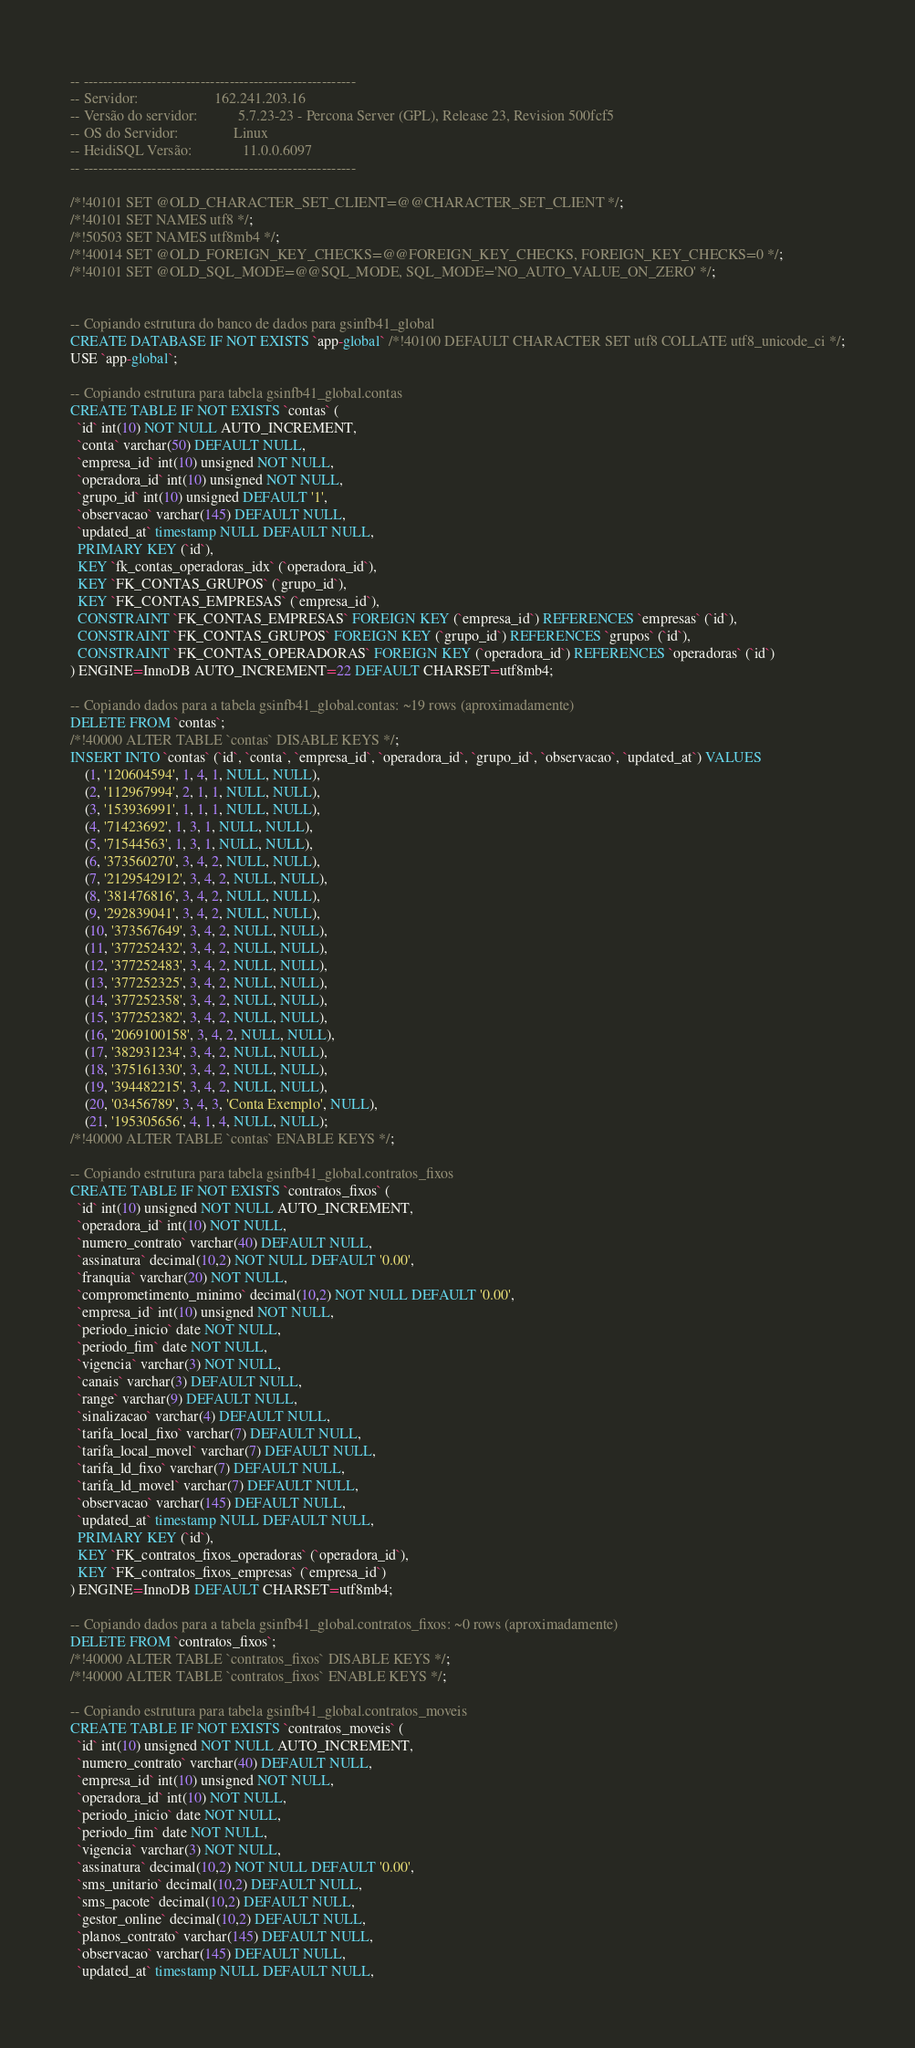Convert code to text. <code><loc_0><loc_0><loc_500><loc_500><_SQL_>-- --------------------------------------------------------
-- Servidor:                     162.241.203.16
-- Versão do servidor:           5.7.23-23 - Percona Server (GPL), Release 23, Revision 500fcf5
-- OS do Servidor:               Linux
-- HeidiSQL Versão:              11.0.0.6097
-- --------------------------------------------------------

/*!40101 SET @OLD_CHARACTER_SET_CLIENT=@@CHARACTER_SET_CLIENT */;
/*!40101 SET NAMES utf8 */;
/*!50503 SET NAMES utf8mb4 */;
/*!40014 SET @OLD_FOREIGN_KEY_CHECKS=@@FOREIGN_KEY_CHECKS, FOREIGN_KEY_CHECKS=0 */;
/*!40101 SET @OLD_SQL_MODE=@@SQL_MODE, SQL_MODE='NO_AUTO_VALUE_ON_ZERO' */;


-- Copiando estrutura do banco de dados para gsinfb41_global
CREATE DATABASE IF NOT EXISTS `app-global` /*!40100 DEFAULT CHARACTER SET utf8 COLLATE utf8_unicode_ci */;
USE `app-global`;

-- Copiando estrutura para tabela gsinfb41_global.contas
CREATE TABLE IF NOT EXISTS `contas` (
  `id` int(10) NOT NULL AUTO_INCREMENT,
  `conta` varchar(50) DEFAULT NULL,
  `empresa_id` int(10) unsigned NOT NULL,
  `operadora_id` int(10) unsigned NOT NULL,
  `grupo_id` int(10) unsigned DEFAULT '1',
  `observacao` varchar(145) DEFAULT NULL,
  `updated_at` timestamp NULL DEFAULT NULL,
  PRIMARY KEY (`id`),
  KEY `fk_contas_operadoras_idx` (`operadora_id`),
  KEY `FK_CONTAS_GRUPOS` (`grupo_id`),
  KEY `FK_CONTAS_EMPRESAS` (`empresa_id`),
  CONSTRAINT `FK_CONTAS_EMPRESAS` FOREIGN KEY (`empresa_id`) REFERENCES `empresas` (`id`),
  CONSTRAINT `FK_CONTAS_GRUPOS` FOREIGN KEY (`grupo_id`) REFERENCES `grupos` (`id`),
  CONSTRAINT `FK_CONTAS_OPERADORAS` FOREIGN KEY (`operadora_id`) REFERENCES `operadoras` (`id`)
) ENGINE=InnoDB AUTO_INCREMENT=22 DEFAULT CHARSET=utf8mb4;

-- Copiando dados para a tabela gsinfb41_global.contas: ~19 rows (aproximadamente)
DELETE FROM `contas`;
/*!40000 ALTER TABLE `contas` DISABLE KEYS */;
INSERT INTO `contas` (`id`, `conta`, `empresa_id`, `operadora_id`, `grupo_id`, `observacao`, `updated_at`) VALUES
	(1, '120604594', 1, 4, 1, NULL, NULL),
	(2, '112967994', 2, 1, 1, NULL, NULL),
	(3, '153936991', 1, 1, 1, NULL, NULL),
	(4, '71423692', 1, 3, 1, NULL, NULL),
	(5, '71544563', 1, 3, 1, NULL, NULL),
	(6, '373560270', 3, 4, 2, NULL, NULL),
	(7, '2129542912', 3, 4, 2, NULL, NULL),
	(8, '381476816', 3, 4, 2, NULL, NULL),
	(9, '292839041', 3, 4, 2, NULL, NULL),
	(10, '373567649', 3, 4, 2, NULL, NULL),
	(11, '377252432', 3, 4, 2, NULL, NULL),
	(12, '377252483', 3, 4, 2, NULL, NULL),
	(13, '377252325', 3, 4, 2, NULL, NULL),
	(14, '377252358', 3, 4, 2, NULL, NULL),
	(15, '377252382', 3, 4, 2, NULL, NULL),
	(16, '2069100158', 3, 4, 2, NULL, NULL),
	(17, '382931234', 3, 4, 2, NULL, NULL),
	(18, '375161330', 3, 4, 2, NULL, NULL),
	(19, '394482215', 3, 4, 2, NULL, NULL),
	(20, '03456789', 3, 4, 3, 'Conta Exemplo', NULL),
	(21, '195305656', 4, 1, 4, NULL, NULL);
/*!40000 ALTER TABLE `contas` ENABLE KEYS */;

-- Copiando estrutura para tabela gsinfb41_global.contratos_fixos
CREATE TABLE IF NOT EXISTS `contratos_fixos` (
  `id` int(10) unsigned NOT NULL AUTO_INCREMENT,
  `operadora_id` int(10) NOT NULL,
  `numero_contrato` varchar(40) DEFAULT NULL,
  `assinatura` decimal(10,2) NOT NULL DEFAULT '0.00',
  `franquia` varchar(20) NOT NULL,
  `comprometimento_minimo` decimal(10,2) NOT NULL DEFAULT '0.00',
  `empresa_id` int(10) unsigned NOT NULL,
  `periodo_inicio` date NOT NULL,
  `periodo_fim` date NOT NULL,
  `vigencia` varchar(3) NOT NULL,
  `canais` varchar(3) DEFAULT NULL,
  `range` varchar(9) DEFAULT NULL,
  `sinalizacao` varchar(4) DEFAULT NULL,
  `tarifa_local_fixo` varchar(7) DEFAULT NULL,
  `tarifa_local_movel` varchar(7) DEFAULT NULL,
  `tarifa_ld_fixo` varchar(7) DEFAULT NULL,
  `tarifa_ld_movel` varchar(7) DEFAULT NULL,
  `observacao` varchar(145) DEFAULT NULL,
  `updated_at` timestamp NULL DEFAULT NULL,
  PRIMARY KEY (`id`),
  KEY `FK_contratos_fixos_operadoras` (`operadora_id`),
  KEY `FK_contratos_fixos_empresas` (`empresa_id`)
) ENGINE=InnoDB DEFAULT CHARSET=utf8mb4;

-- Copiando dados para a tabela gsinfb41_global.contratos_fixos: ~0 rows (aproximadamente)
DELETE FROM `contratos_fixos`;
/*!40000 ALTER TABLE `contratos_fixos` DISABLE KEYS */;
/*!40000 ALTER TABLE `contratos_fixos` ENABLE KEYS */;

-- Copiando estrutura para tabela gsinfb41_global.contratos_moveis
CREATE TABLE IF NOT EXISTS `contratos_moveis` (
  `id` int(10) unsigned NOT NULL AUTO_INCREMENT,
  `numero_contrato` varchar(40) DEFAULT NULL,
  `empresa_id` int(10) unsigned NOT NULL,
  `operadora_id` int(10) NOT NULL,
  `periodo_inicio` date NOT NULL,
  `periodo_fim` date NOT NULL,
  `vigencia` varchar(3) NOT NULL,
  `assinatura` decimal(10,2) NOT NULL DEFAULT '0.00',
  `sms_unitario` decimal(10,2) DEFAULT NULL,
  `sms_pacote` decimal(10,2) DEFAULT NULL,
  `gestor_online` decimal(10,2) DEFAULT NULL,
  `planos_contrato` varchar(145) DEFAULT NULL,
  `observacao` varchar(145) DEFAULT NULL,
  `updated_at` timestamp NULL DEFAULT NULL,</code> 